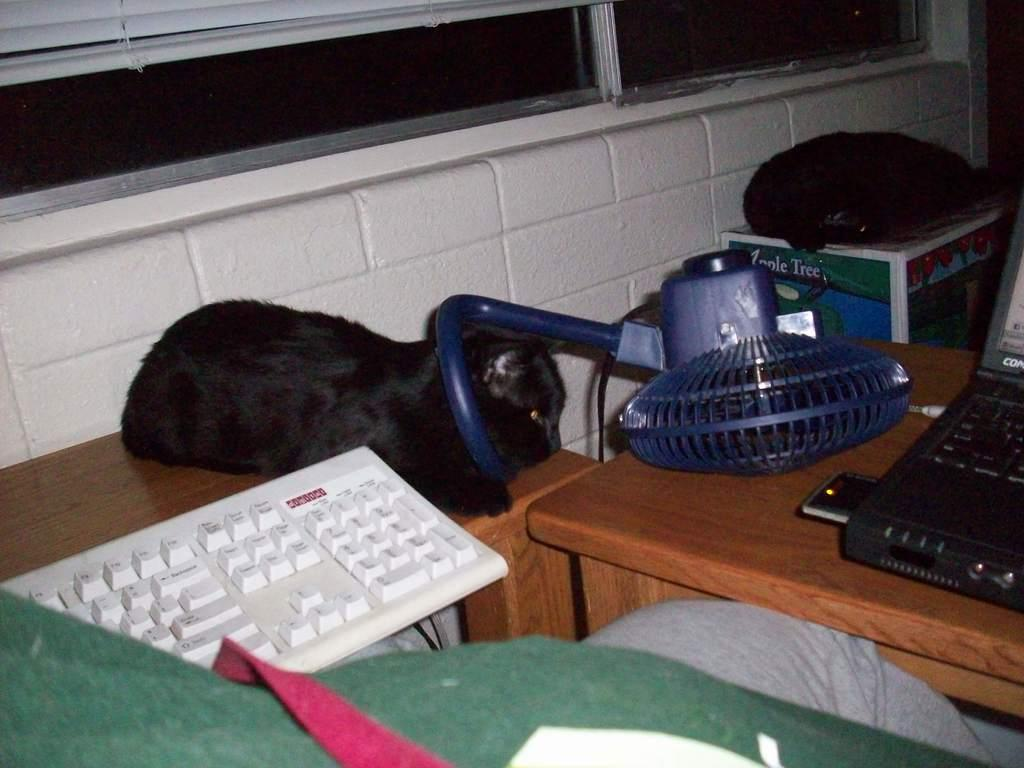Where is the setting of the image? The image is inside a room. What electronic device is on the table in the image? There is a keyboard and a computer on the table in the image. What appliance is also on the table? There is a fan on the table in the image. What other object can be seen on the table? There is a bag on the table in the image. What animal is present in the image? There is a black cat sitting on the table in the image. What type of coat is the hospital wearing in the image? There is no hospital or coat present in the image. What action is the cat performing in the image? The image only shows the black cat sitting on the table, so it is not performing any specific action. 